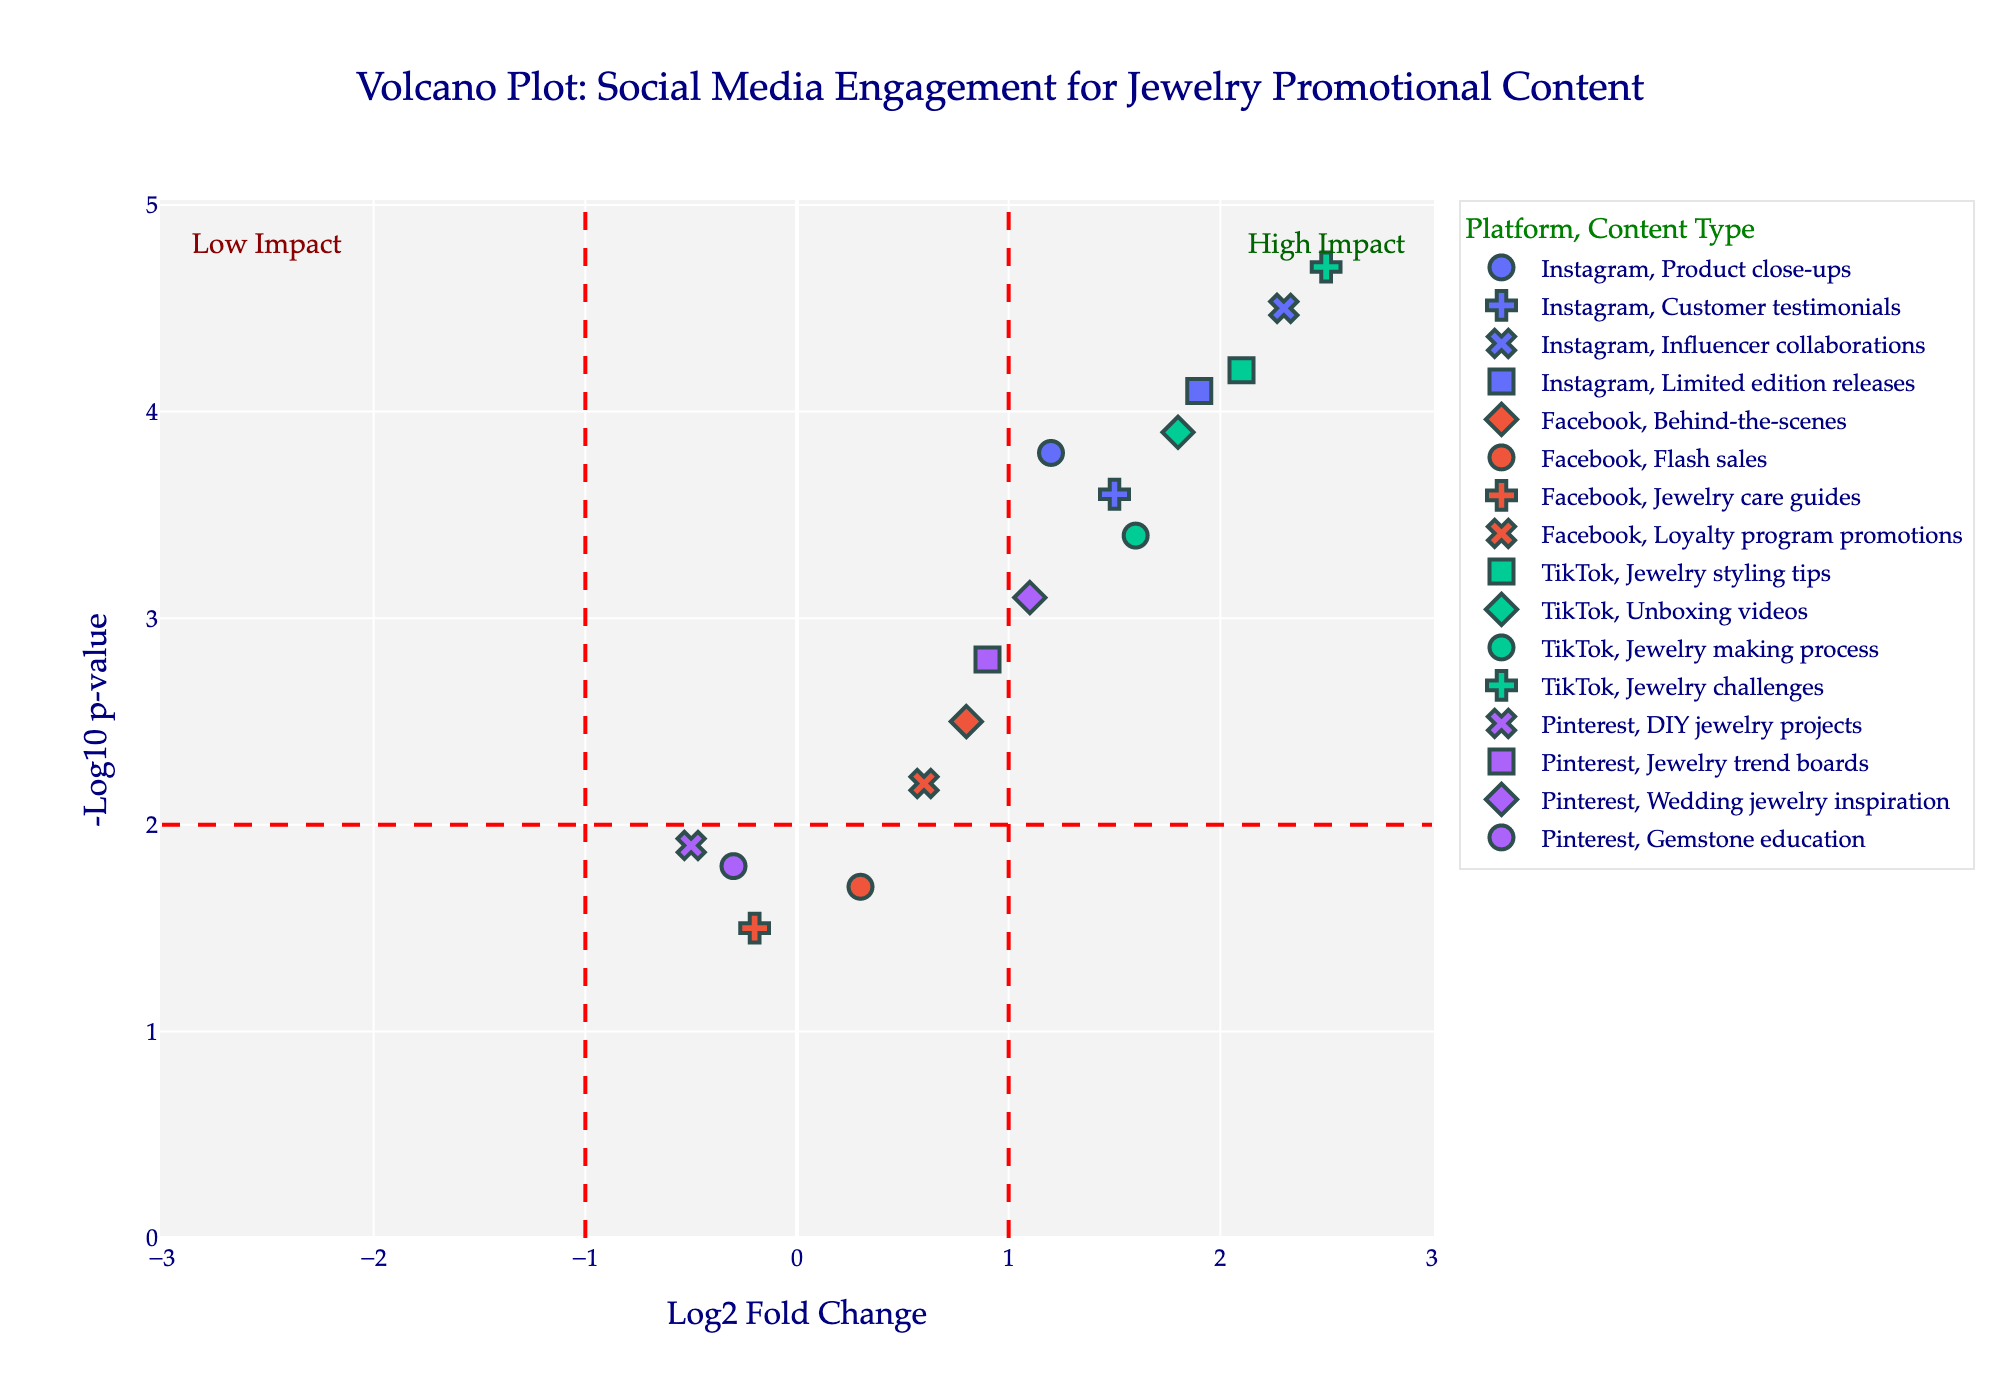What is the title of the figure? The title of the figure can be found at the top and is usually descriptive of the data presented.
Answer: Volcano Plot: Social Media Engagement for Jewelry Promotional Content How many platforms are represented in the plot? Count the unique colors in the plot, which correspond to different platforms.
Answer: Four Which content type has the highest log2 fold change on TikTok? Locate data points for TikTok and identify the one with the highest log2 fold change value.
Answer: Jewelry challenges Which Instagram content type has a higher engagement, Limited edition releases or Customer testimonials? Compare the log2 fold changes of Limited edition releases and Customer testimonials on Instagram.
Answer: Limited edition releases How many content types have both high fold change and high statistical significance? High fold change is indicated by log2 fold change > 1 or < -1, and high significance is indicated by negative log10 p-value > 2. Count data points fitting these criteria.
Answer: Six What is the negative log10 p-value for Influencer collaborations on Instagram? Identify the data point for Instagram's Influencer collaborations and read its negative log10 p-value.
Answer: 4.5 Which platform has the most content types with negative log2 fold changes? Count the number of data points with negative log2 fold changes for each platform.
Answer: Pinterest Which TikTok content type has the lowest statistical significance? Locate TikTok data points and identify the one with the lowest negative log10 p-value.
Answer: Jewelry making process Compare the log2 fold changes of Product close-ups on Instagram and Jewelry styling tips on TikTok. Identify the log2 fold changes for both and compare them directly.
Answer: 1.2 (Product close-ups) vs. 2.1 (Jewelry styling tips) What does red dashed vertical and horizontal lines indicate? Examine the annotation and the position of the lines on the plot. They offer a threshold for comparing values.
Answer: Fold change and p-value thresholds 